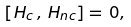<formula> <loc_0><loc_0><loc_500><loc_500>[ H _ { c } \, , \, H _ { n c } ] = \, 0 ,</formula> 